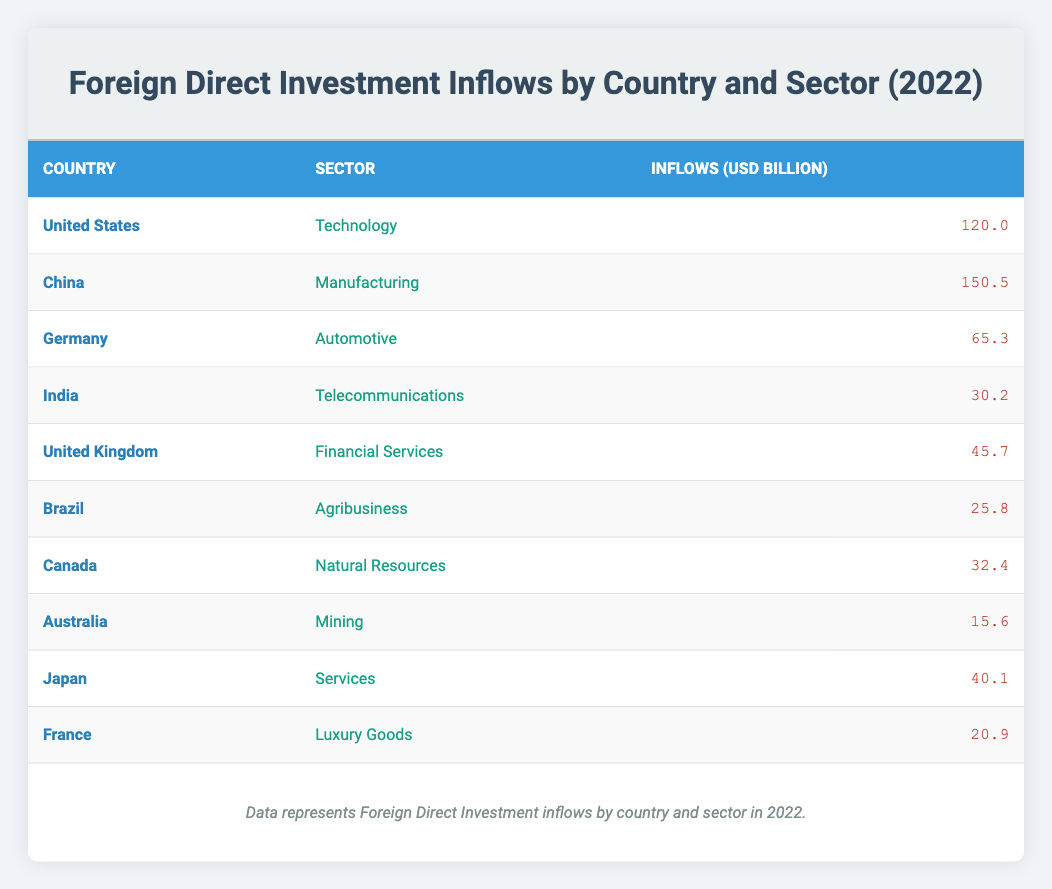What is the highest amount of Foreign Direct Investment inflow in the table? According to the table, the highest inflow is listed under China for the Manufacturing sector, which is 150.5 billion USD.
Answer: 150.5 billion USD Which country received the lowest FDI inflow and what was the amount? The lowest FDI inflow in the table belongs to Australia, with an amount of 15.6 billion USD in the Mining sector.
Answer: Australia, 15.6 billion USD What is the total Foreign Direct Investment inflow from the top three countries? The top three countries based on inflows are China (150.5), United States (120.0), and Germany (65.3). Adding these amounts together gives 150.5 + 120.0 + 65.3 = 335.8 billion USD.
Answer: 335.8 billion USD Is the inflow from India higher than the inflow from Brazil? The FDI inflow from India is 30.2 billion USD while Brazil's is 25.8 billion USD. Since 30.2 is greater than 25.8, the statement is true.
Answer: Yes What sector attracted the second highest inflow of Foreign Direct Investment? After reviewing the inflows, the Manufacturing sector (China, 150.5 billion USD) is the highest, followed by the Technology sector (United States, 120.0 billion USD). This confirms that Technology attracted the second highest inflow.
Answer: Technology What is the average Foreign Direct Investment inflow across all countries listed in the table? To find the average inflow, we first sum all inflows: (120.0 + 150.5 + 65.3 + 30.2 + 45.7 + 25.8 + 32.4 + 15.6 + 40.1 + 20.9) =  5 inflows, which sum up to  610.1 billion USD, and there are 10 countries. Therefore, 610.1 / 10 = 61.01 billion USD is the average.
Answer: 61.01 billion USD Which country has an inflow in the Service sector, and what is the amount? The table shows that Japan is the only country listed under the Services sector, with an inflow of 40.1 billion USD.
Answer: Japan, 40.1 billion USD Are there any countries listed that have an FDI inflow of less than 40 billion USD? The countries with inflows of less than 40 billion USD include Brazil (25.8), Canada (32.4), India (30.2), and Australia (15.6). Therefore, the statement is true.
Answer: Yes What is the total inflow from the sectors of Financial Services and Luxury Goods combined? The inflow from Financial Services (United Kingdom) is 45.7 billion USD and from Luxury Goods (France) is 20.9 billion USD. Summing these gives 45.7 + 20.9 = 66.6 billion USD as the total inflow from these sectors.
Answer: 66.6 billion USD 